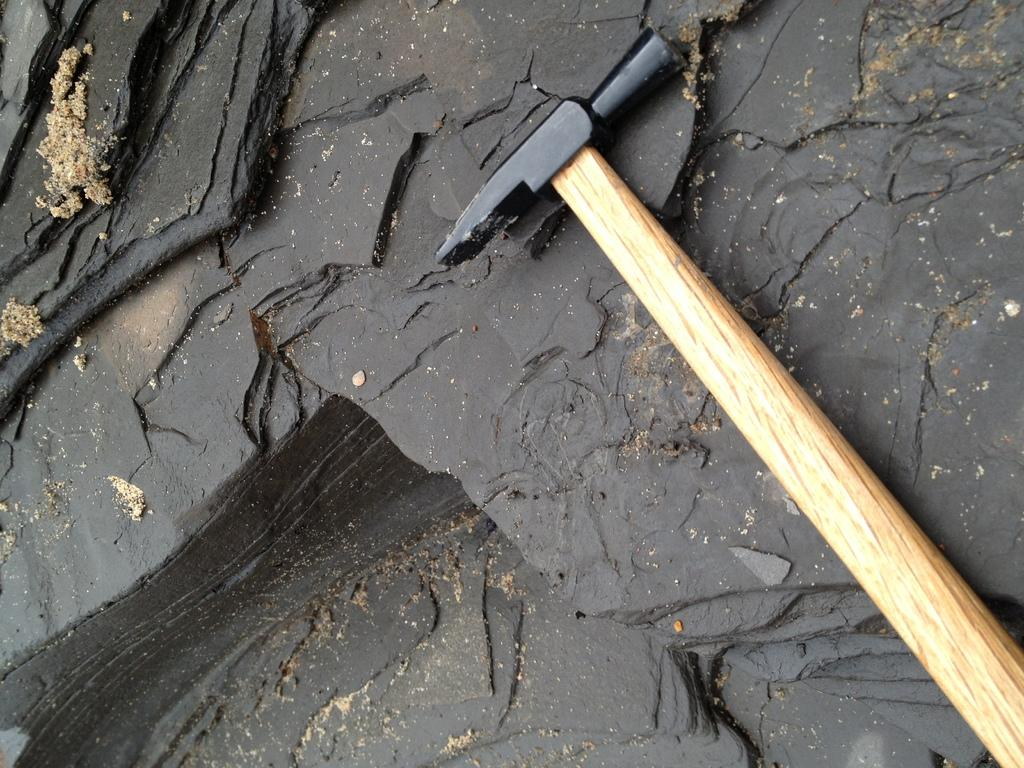What object is present in the image? There is a hammer in the image. Where is the hammer located? The hammer is on a rock. What type of spot can be seen on the hammer in the image? There is no spot visible on the hammer in the image. 